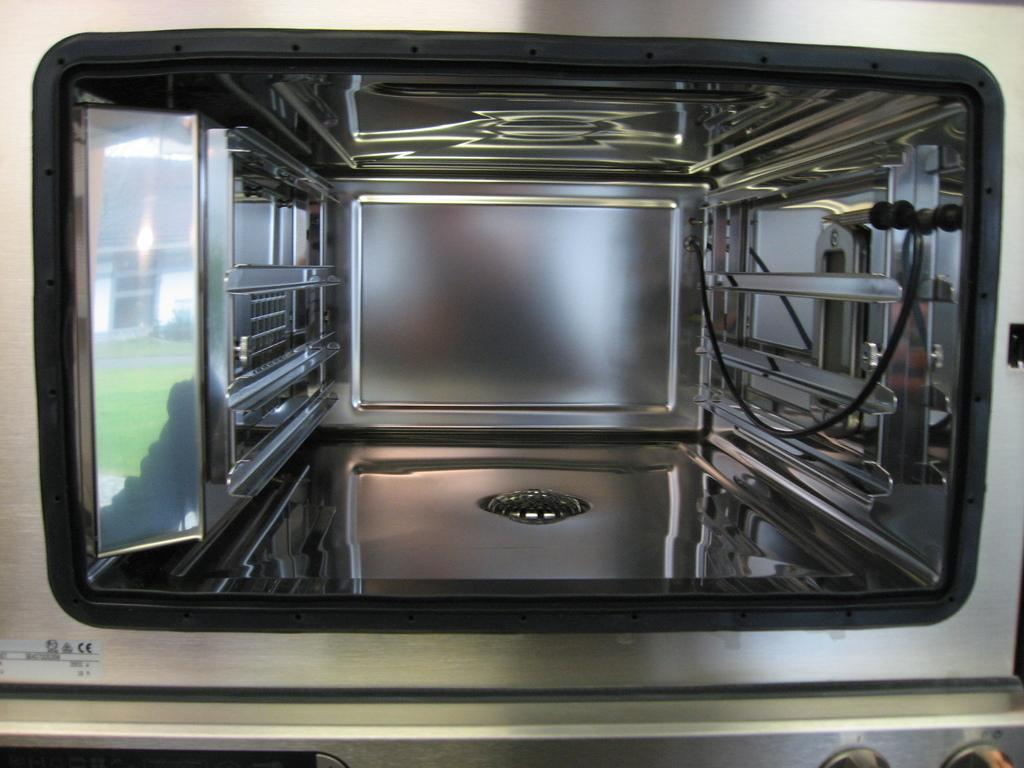What is the main subject of the image? The main subject of the image is the inside view of an oven. What is the tendency of the quill in the image? There is no quill present in the image, as it only shows the inside view of an oven. 